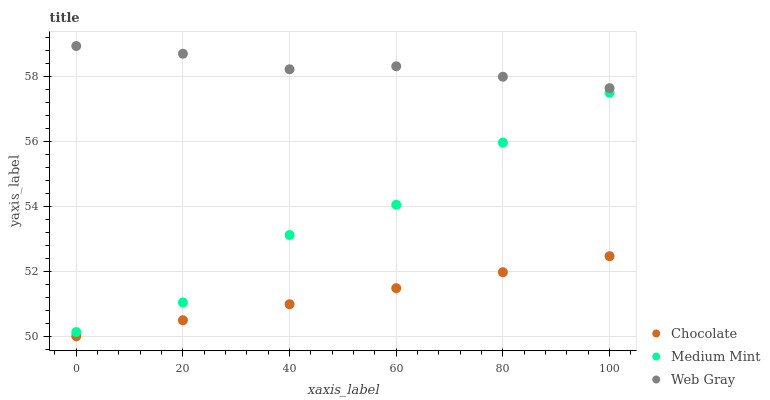Does Chocolate have the minimum area under the curve?
Answer yes or no. Yes. Does Web Gray have the maximum area under the curve?
Answer yes or no. Yes. Does Web Gray have the minimum area under the curve?
Answer yes or no. No. Does Chocolate have the maximum area under the curve?
Answer yes or no. No. Is Chocolate the smoothest?
Answer yes or no. Yes. Is Medium Mint the roughest?
Answer yes or no. Yes. Is Web Gray the smoothest?
Answer yes or no. No. Is Web Gray the roughest?
Answer yes or no. No. Does Chocolate have the lowest value?
Answer yes or no. Yes. Does Web Gray have the lowest value?
Answer yes or no. No. Does Web Gray have the highest value?
Answer yes or no. Yes. Does Chocolate have the highest value?
Answer yes or no. No. Is Medium Mint less than Web Gray?
Answer yes or no. Yes. Is Web Gray greater than Medium Mint?
Answer yes or no. Yes. Does Medium Mint intersect Web Gray?
Answer yes or no. No. 